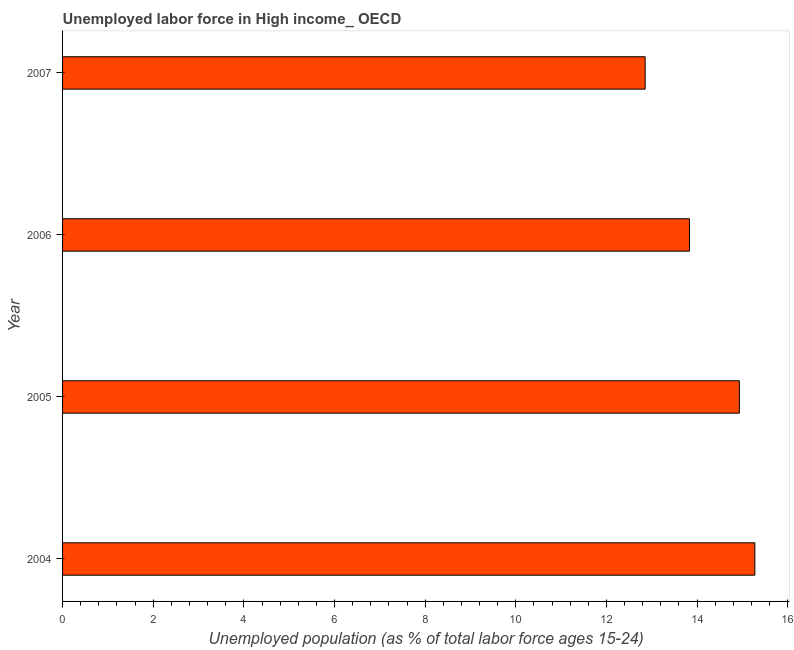Does the graph contain any zero values?
Ensure brevity in your answer.  No. Does the graph contain grids?
Provide a succinct answer. No. What is the title of the graph?
Provide a short and direct response. Unemployed labor force in High income_ OECD. What is the label or title of the X-axis?
Offer a terse response. Unemployed population (as % of total labor force ages 15-24). What is the label or title of the Y-axis?
Provide a succinct answer. Year. What is the total unemployed youth population in 2004?
Keep it short and to the point. 15.27. Across all years, what is the maximum total unemployed youth population?
Provide a succinct answer. 15.27. Across all years, what is the minimum total unemployed youth population?
Offer a terse response. 12.85. What is the sum of the total unemployed youth population?
Make the answer very short. 56.89. What is the difference between the total unemployed youth population in 2004 and 2006?
Your response must be concise. 1.44. What is the average total unemployed youth population per year?
Your answer should be very brief. 14.22. What is the median total unemployed youth population?
Ensure brevity in your answer.  14.38. In how many years, is the total unemployed youth population greater than 6.8 %?
Provide a succinct answer. 4. Do a majority of the years between 2007 and 2005 (inclusive) have total unemployed youth population greater than 12.8 %?
Make the answer very short. Yes. What is the ratio of the total unemployed youth population in 2004 to that in 2006?
Provide a short and direct response. 1.1. Is the total unemployed youth population in 2004 less than that in 2006?
Offer a very short reply. No. Is the difference between the total unemployed youth population in 2004 and 2005 greater than the difference between any two years?
Keep it short and to the point. No. What is the difference between the highest and the second highest total unemployed youth population?
Offer a terse response. 0.34. What is the difference between the highest and the lowest total unemployed youth population?
Offer a very short reply. 2.42. In how many years, is the total unemployed youth population greater than the average total unemployed youth population taken over all years?
Your answer should be very brief. 2. Are all the bars in the graph horizontal?
Provide a succinct answer. Yes. What is the difference between two consecutive major ticks on the X-axis?
Offer a terse response. 2. What is the Unemployed population (as % of total labor force ages 15-24) in 2004?
Provide a short and direct response. 15.27. What is the Unemployed population (as % of total labor force ages 15-24) in 2005?
Offer a very short reply. 14.93. What is the Unemployed population (as % of total labor force ages 15-24) of 2006?
Keep it short and to the point. 13.83. What is the Unemployed population (as % of total labor force ages 15-24) of 2007?
Your answer should be compact. 12.85. What is the difference between the Unemployed population (as % of total labor force ages 15-24) in 2004 and 2005?
Ensure brevity in your answer.  0.34. What is the difference between the Unemployed population (as % of total labor force ages 15-24) in 2004 and 2006?
Your answer should be compact. 1.44. What is the difference between the Unemployed population (as % of total labor force ages 15-24) in 2004 and 2007?
Offer a terse response. 2.42. What is the difference between the Unemployed population (as % of total labor force ages 15-24) in 2005 and 2006?
Keep it short and to the point. 1.1. What is the difference between the Unemployed population (as % of total labor force ages 15-24) in 2005 and 2007?
Provide a succinct answer. 2.08. What is the difference between the Unemployed population (as % of total labor force ages 15-24) in 2006 and 2007?
Offer a very short reply. 0.98. What is the ratio of the Unemployed population (as % of total labor force ages 15-24) in 2004 to that in 2006?
Give a very brief answer. 1.1. What is the ratio of the Unemployed population (as % of total labor force ages 15-24) in 2004 to that in 2007?
Make the answer very short. 1.19. What is the ratio of the Unemployed population (as % of total labor force ages 15-24) in 2005 to that in 2006?
Provide a succinct answer. 1.08. What is the ratio of the Unemployed population (as % of total labor force ages 15-24) in 2005 to that in 2007?
Offer a very short reply. 1.16. What is the ratio of the Unemployed population (as % of total labor force ages 15-24) in 2006 to that in 2007?
Provide a short and direct response. 1.08. 